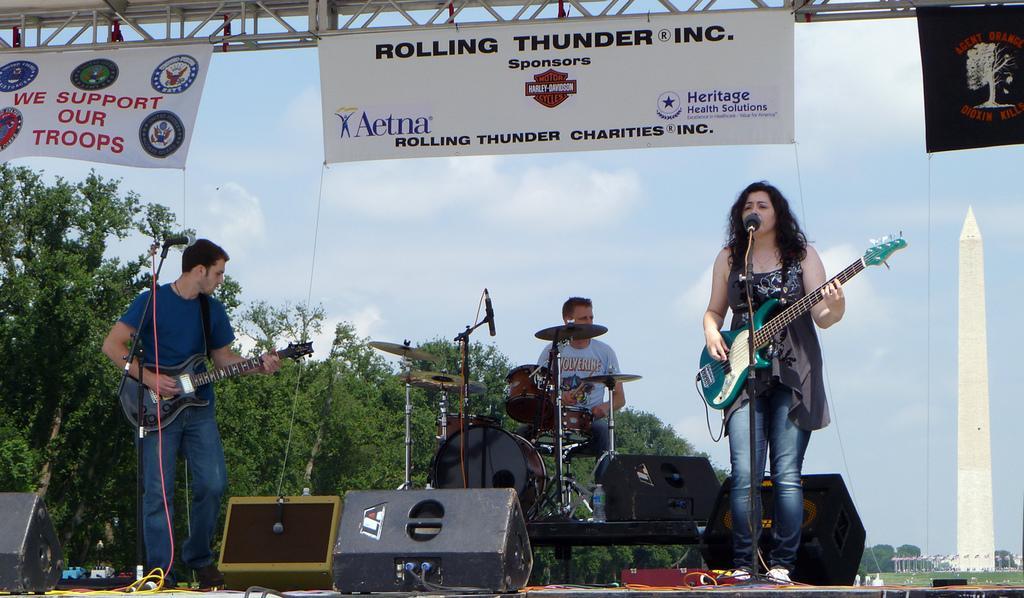Can you describe this image briefly? In this image i can see 2 persons standing and holding guitar in their hands and a person sitting in front of musical instruments, i can see microphones in front of them. In the background i can see trees, sky and few banners. 